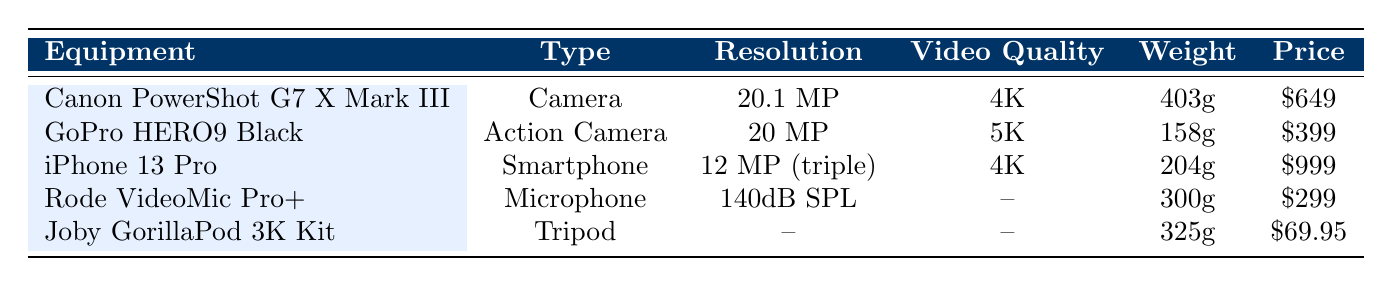What is the video quality of the GoPro HERO9 Black? The GoPro HERO9 Black is listed in the table with its respective video quality indicated as 5K.
Answer: 5K Which equipment has the highest resolution? The highest resolution in the table is found in the Canon PowerShot G7 X Mark III, which has a resolution of 20.1 MP.
Answer: 20.1 MP Is the Rode VideoMic Pro+ the lightest piece of equipment listed? To determine this, we can compare the weights: Rode VideoMic Pro+ (300g), Canon PowerShot G7 X Mark III (403g), GoPro HERO9 Black (158g), iPhone 13 Pro (204g), and Joby GorillaPod 3K Kit (325g). The GoPro HERO9 Black is the lightest at 158g.
Answer: No What is the combined weight of the Canon PowerShot G7 X Mark III and the iPhone 13 Pro? Adding their weights: Canon PowerShot G7 X Mark III (403g) + iPhone 13 Pro (204g) = 607g.
Answer: 607g Does the Joby GorillaPod 3K Kit have any specified resolution or video quality? Checking the table for the Joby GorillaPod 3K Kit, it indicates no specified resolution or video quality, which is denoted by "--" in the respective columns.
Answer: Yes Which equipment provides the longest battery life for video recording? The equipment with the longest battery life is the iPhone 13 Pro at up to 22 hours for video playback. Comparing this to the other equipment, which either provides a finite number of shots or hours, the iPhone 13 Pro outlasts the others based on the given data.
Answer: iPhone 13 Pro How much does the GoPro HERO9 Black cost compared to the Rode VideoMic Pro+? By referring to the prices: GoPro HERO9 Black at $399 and Rode VideoMic Pro+ at $299, the difference is calculated as $399 - $299 = $100.
Answer: $100 What features does the Canon PowerShot G7 X Mark III have that the iPhone 13 Pro lacks? Looking at the features listed for both, the Canon PowerShot G7 X Mark III includes built-in stabilization, a flip-up touchscreen, and live streaming capability, while the iPhone 13 Pro focuses on video recording capabilities without these specific features.
Answer: Built-in stabilization, Flip-up touchscreen, Live streaming capability 